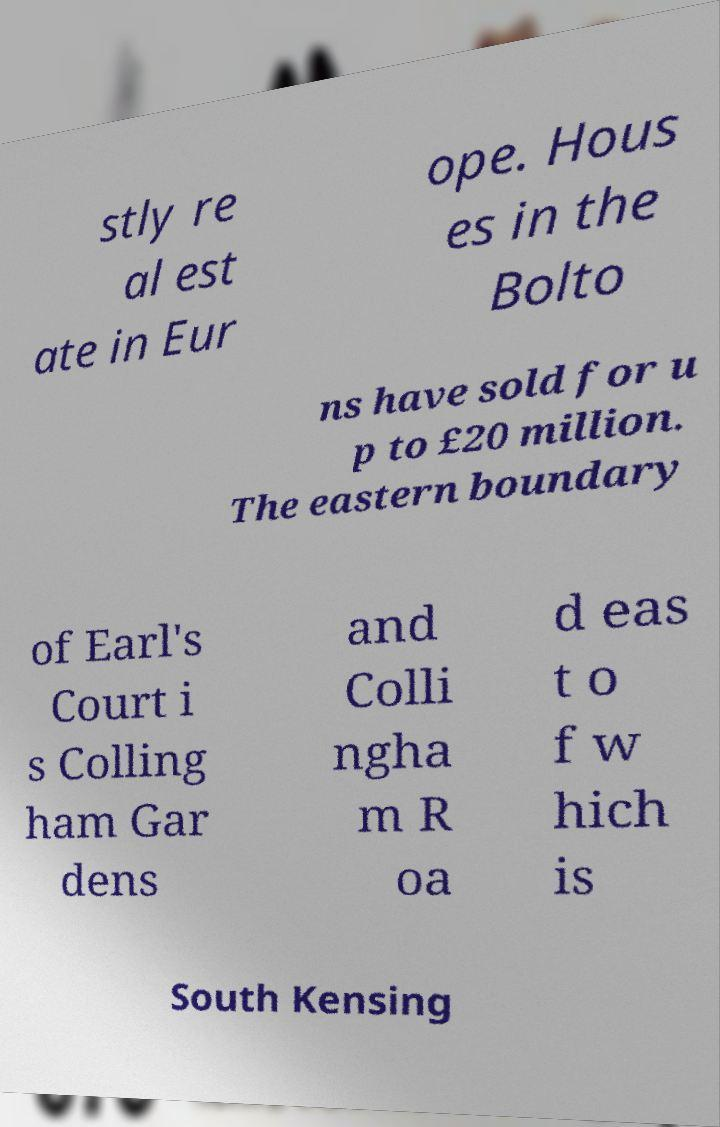What messages or text are displayed in this image? I need them in a readable, typed format. stly re al est ate in Eur ope. Hous es in the Bolto ns have sold for u p to £20 million. The eastern boundary of Earl's Court i s Colling ham Gar dens and Colli ngha m R oa d eas t o f w hich is South Kensing 